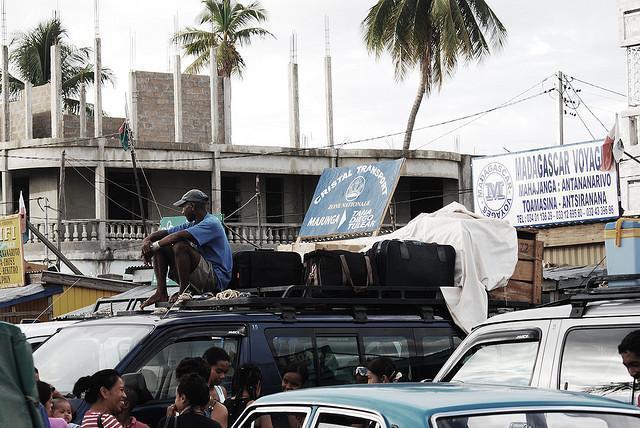These people are on what continent?
Pick the correct solution from the four options below to address the question.
Options: Asia, south america, africa, north america. Africa. 